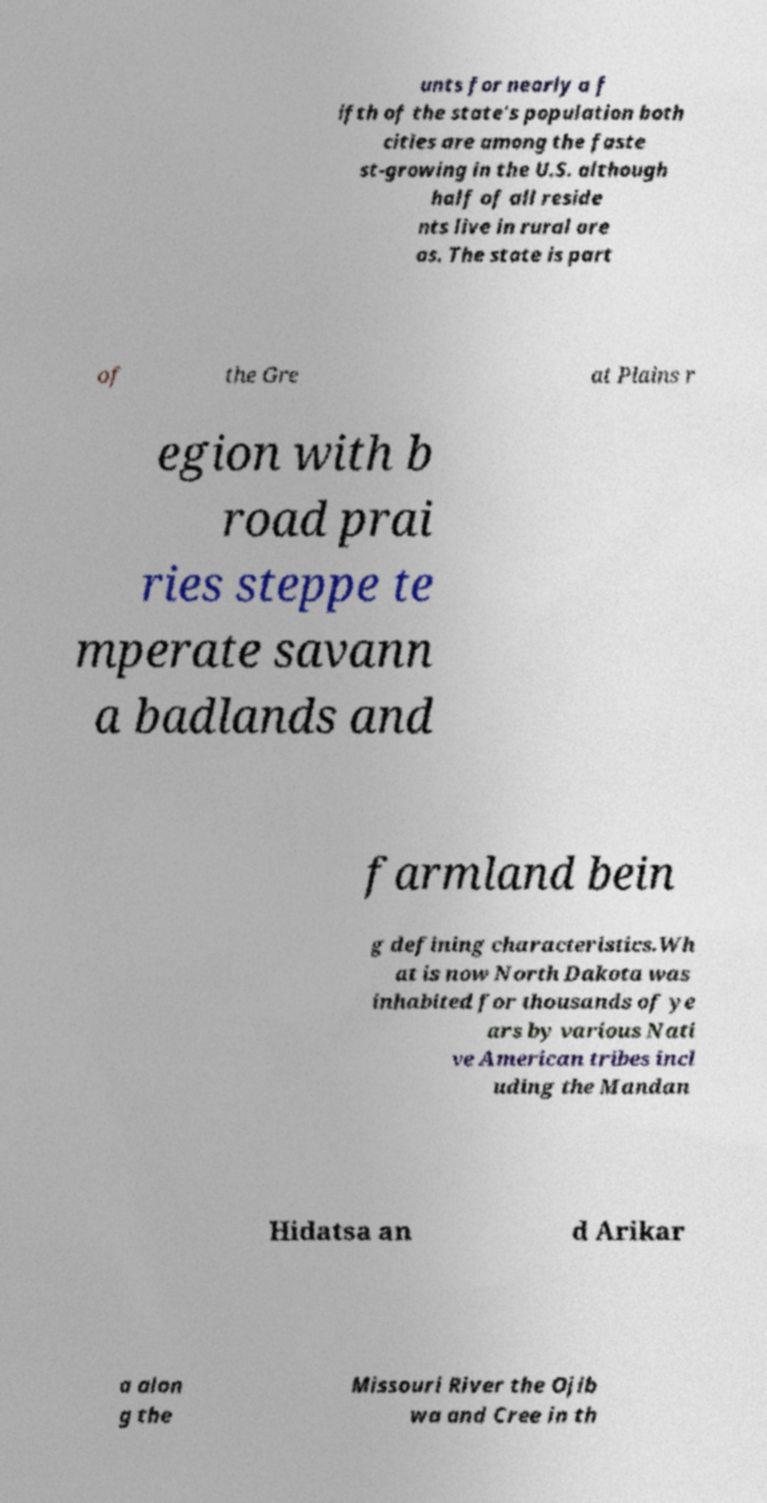Could you extract and type out the text from this image? unts for nearly a f ifth of the state's population both cities are among the faste st-growing in the U.S. although half of all reside nts live in rural are as. The state is part of the Gre at Plains r egion with b road prai ries steppe te mperate savann a badlands and farmland bein g defining characteristics.Wh at is now North Dakota was inhabited for thousands of ye ars by various Nati ve American tribes incl uding the Mandan Hidatsa an d Arikar a alon g the Missouri River the Ojib wa and Cree in th 